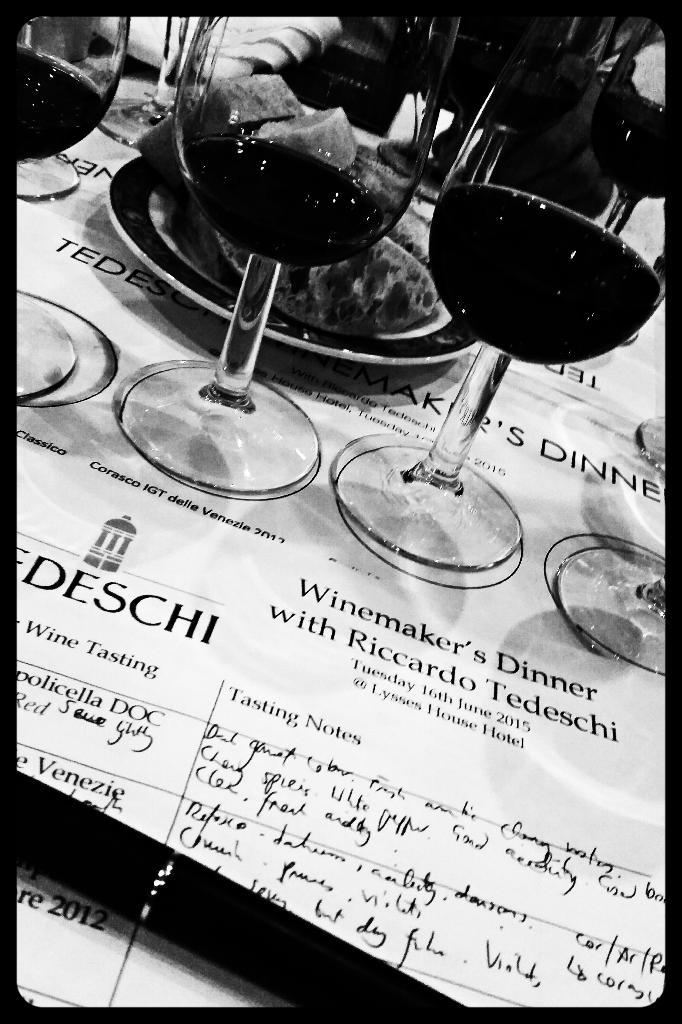What objects are visible in the image that are typically used for consuming beverages? There are glasses in the image. What is inside the glasses? There are drinks in the glasses. What is present on the plate in the image? There is something on the plate. Can you describe any text or symbols in the image? There is writing in the image at a few places. What type of chalk is being used to write on the plate in the image? There is no chalk present in the image, and no writing is observed on the plate. 